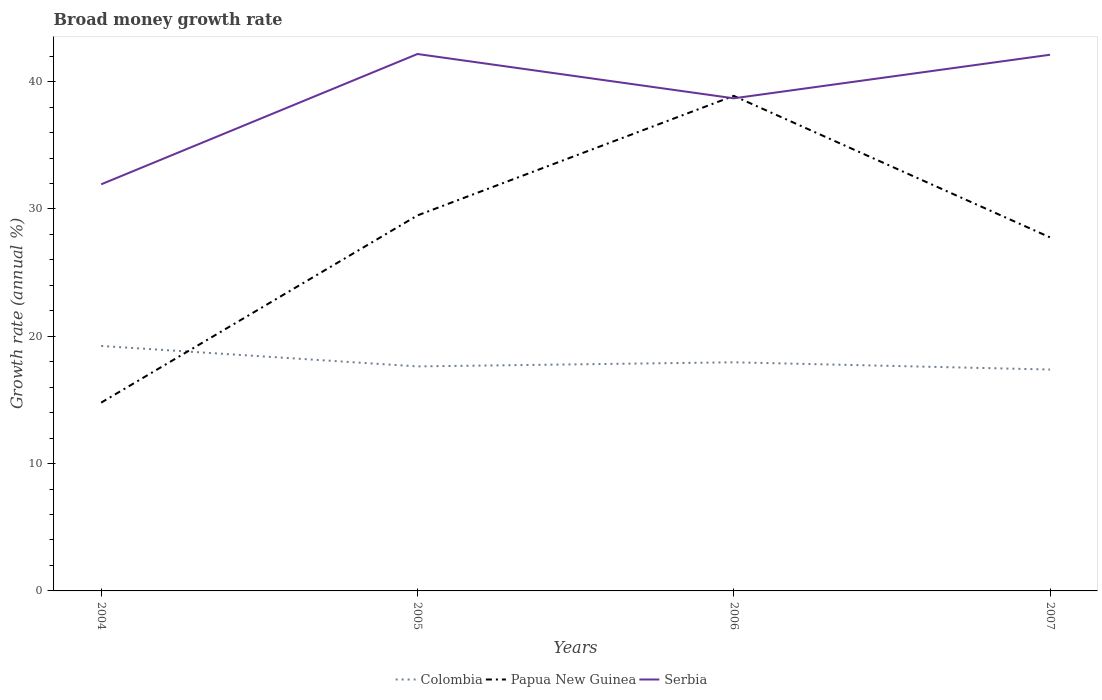How many different coloured lines are there?
Your answer should be very brief. 3. Across all years, what is the maximum growth rate in Papua New Guinea?
Provide a succinct answer. 14.79. In which year was the growth rate in Papua New Guinea maximum?
Your answer should be very brief. 2004. What is the total growth rate in Papua New Guinea in the graph?
Provide a succinct answer. -12.98. What is the difference between the highest and the second highest growth rate in Papua New Guinea?
Give a very brief answer. 24.09. What is the difference between the highest and the lowest growth rate in Serbia?
Offer a very short reply. 2. Is the growth rate in Papua New Guinea strictly greater than the growth rate in Colombia over the years?
Ensure brevity in your answer.  No. How many lines are there?
Your answer should be very brief. 3. How many years are there in the graph?
Provide a succinct answer. 4. Are the values on the major ticks of Y-axis written in scientific E-notation?
Your answer should be very brief. No. Does the graph contain any zero values?
Keep it short and to the point. No. Does the graph contain grids?
Provide a short and direct response. No. How are the legend labels stacked?
Keep it short and to the point. Horizontal. What is the title of the graph?
Give a very brief answer. Broad money growth rate. What is the label or title of the Y-axis?
Your answer should be compact. Growth rate (annual %). What is the Growth rate (annual %) in Colombia in 2004?
Ensure brevity in your answer.  19.24. What is the Growth rate (annual %) in Papua New Guinea in 2004?
Your answer should be very brief. 14.79. What is the Growth rate (annual %) of Serbia in 2004?
Offer a terse response. 31.93. What is the Growth rate (annual %) of Colombia in 2005?
Keep it short and to the point. 17.63. What is the Growth rate (annual %) of Papua New Guinea in 2005?
Provide a short and direct response. 29.49. What is the Growth rate (annual %) of Serbia in 2005?
Your answer should be very brief. 42.17. What is the Growth rate (annual %) of Colombia in 2006?
Ensure brevity in your answer.  17.95. What is the Growth rate (annual %) of Papua New Guinea in 2006?
Your answer should be compact. 38.88. What is the Growth rate (annual %) in Serbia in 2006?
Your response must be concise. 38.69. What is the Growth rate (annual %) in Colombia in 2007?
Ensure brevity in your answer.  17.39. What is the Growth rate (annual %) in Papua New Guinea in 2007?
Ensure brevity in your answer.  27.76. What is the Growth rate (annual %) of Serbia in 2007?
Make the answer very short. 42.11. Across all years, what is the maximum Growth rate (annual %) in Colombia?
Offer a very short reply. 19.24. Across all years, what is the maximum Growth rate (annual %) in Papua New Guinea?
Your answer should be very brief. 38.88. Across all years, what is the maximum Growth rate (annual %) of Serbia?
Ensure brevity in your answer.  42.17. Across all years, what is the minimum Growth rate (annual %) of Colombia?
Your answer should be very brief. 17.39. Across all years, what is the minimum Growth rate (annual %) of Papua New Guinea?
Your answer should be very brief. 14.79. Across all years, what is the minimum Growth rate (annual %) in Serbia?
Provide a succinct answer. 31.93. What is the total Growth rate (annual %) of Colombia in the graph?
Provide a succinct answer. 72.21. What is the total Growth rate (annual %) in Papua New Guinea in the graph?
Your response must be concise. 110.92. What is the total Growth rate (annual %) in Serbia in the graph?
Make the answer very short. 154.9. What is the difference between the Growth rate (annual %) of Colombia in 2004 and that in 2005?
Ensure brevity in your answer.  1.61. What is the difference between the Growth rate (annual %) in Papua New Guinea in 2004 and that in 2005?
Provide a succinct answer. -14.7. What is the difference between the Growth rate (annual %) of Serbia in 2004 and that in 2005?
Provide a short and direct response. -10.23. What is the difference between the Growth rate (annual %) of Colombia in 2004 and that in 2006?
Keep it short and to the point. 1.29. What is the difference between the Growth rate (annual %) in Papua New Guinea in 2004 and that in 2006?
Make the answer very short. -24.09. What is the difference between the Growth rate (annual %) in Serbia in 2004 and that in 2006?
Offer a very short reply. -6.76. What is the difference between the Growth rate (annual %) in Colombia in 2004 and that in 2007?
Offer a terse response. 1.85. What is the difference between the Growth rate (annual %) of Papua New Guinea in 2004 and that in 2007?
Ensure brevity in your answer.  -12.98. What is the difference between the Growth rate (annual %) of Serbia in 2004 and that in 2007?
Offer a terse response. -10.18. What is the difference between the Growth rate (annual %) of Colombia in 2005 and that in 2006?
Provide a succinct answer. -0.32. What is the difference between the Growth rate (annual %) of Papua New Guinea in 2005 and that in 2006?
Your answer should be compact. -9.39. What is the difference between the Growth rate (annual %) in Serbia in 2005 and that in 2006?
Provide a short and direct response. 3.48. What is the difference between the Growth rate (annual %) of Colombia in 2005 and that in 2007?
Give a very brief answer. 0.25. What is the difference between the Growth rate (annual %) in Papua New Guinea in 2005 and that in 2007?
Give a very brief answer. 1.73. What is the difference between the Growth rate (annual %) in Serbia in 2005 and that in 2007?
Give a very brief answer. 0.06. What is the difference between the Growth rate (annual %) in Colombia in 2006 and that in 2007?
Offer a terse response. 0.57. What is the difference between the Growth rate (annual %) of Papua New Guinea in 2006 and that in 2007?
Offer a very short reply. 11.11. What is the difference between the Growth rate (annual %) in Serbia in 2006 and that in 2007?
Ensure brevity in your answer.  -3.42. What is the difference between the Growth rate (annual %) in Colombia in 2004 and the Growth rate (annual %) in Papua New Guinea in 2005?
Provide a short and direct response. -10.25. What is the difference between the Growth rate (annual %) of Colombia in 2004 and the Growth rate (annual %) of Serbia in 2005?
Give a very brief answer. -22.93. What is the difference between the Growth rate (annual %) in Papua New Guinea in 2004 and the Growth rate (annual %) in Serbia in 2005?
Offer a terse response. -27.38. What is the difference between the Growth rate (annual %) in Colombia in 2004 and the Growth rate (annual %) in Papua New Guinea in 2006?
Ensure brevity in your answer.  -19.64. What is the difference between the Growth rate (annual %) of Colombia in 2004 and the Growth rate (annual %) of Serbia in 2006?
Ensure brevity in your answer.  -19.45. What is the difference between the Growth rate (annual %) of Papua New Guinea in 2004 and the Growth rate (annual %) of Serbia in 2006?
Offer a terse response. -23.9. What is the difference between the Growth rate (annual %) in Colombia in 2004 and the Growth rate (annual %) in Papua New Guinea in 2007?
Offer a terse response. -8.52. What is the difference between the Growth rate (annual %) in Colombia in 2004 and the Growth rate (annual %) in Serbia in 2007?
Make the answer very short. -22.87. What is the difference between the Growth rate (annual %) in Papua New Guinea in 2004 and the Growth rate (annual %) in Serbia in 2007?
Make the answer very short. -27.32. What is the difference between the Growth rate (annual %) of Colombia in 2005 and the Growth rate (annual %) of Papua New Guinea in 2006?
Give a very brief answer. -21.25. What is the difference between the Growth rate (annual %) in Colombia in 2005 and the Growth rate (annual %) in Serbia in 2006?
Your answer should be very brief. -21.06. What is the difference between the Growth rate (annual %) of Papua New Guinea in 2005 and the Growth rate (annual %) of Serbia in 2006?
Keep it short and to the point. -9.2. What is the difference between the Growth rate (annual %) in Colombia in 2005 and the Growth rate (annual %) in Papua New Guinea in 2007?
Keep it short and to the point. -10.13. What is the difference between the Growth rate (annual %) in Colombia in 2005 and the Growth rate (annual %) in Serbia in 2007?
Offer a terse response. -24.48. What is the difference between the Growth rate (annual %) in Papua New Guinea in 2005 and the Growth rate (annual %) in Serbia in 2007?
Your response must be concise. -12.62. What is the difference between the Growth rate (annual %) of Colombia in 2006 and the Growth rate (annual %) of Papua New Guinea in 2007?
Your answer should be very brief. -9.81. What is the difference between the Growth rate (annual %) of Colombia in 2006 and the Growth rate (annual %) of Serbia in 2007?
Give a very brief answer. -24.15. What is the difference between the Growth rate (annual %) of Papua New Guinea in 2006 and the Growth rate (annual %) of Serbia in 2007?
Offer a terse response. -3.23. What is the average Growth rate (annual %) in Colombia per year?
Make the answer very short. 18.05. What is the average Growth rate (annual %) in Papua New Guinea per year?
Offer a very short reply. 27.73. What is the average Growth rate (annual %) of Serbia per year?
Make the answer very short. 38.72. In the year 2004, what is the difference between the Growth rate (annual %) in Colombia and Growth rate (annual %) in Papua New Guinea?
Provide a succinct answer. 4.45. In the year 2004, what is the difference between the Growth rate (annual %) of Colombia and Growth rate (annual %) of Serbia?
Your answer should be very brief. -12.69. In the year 2004, what is the difference between the Growth rate (annual %) in Papua New Guinea and Growth rate (annual %) in Serbia?
Give a very brief answer. -17.15. In the year 2005, what is the difference between the Growth rate (annual %) of Colombia and Growth rate (annual %) of Papua New Guinea?
Your answer should be compact. -11.86. In the year 2005, what is the difference between the Growth rate (annual %) of Colombia and Growth rate (annual %) of Serbia?
Provide a short and direct response. -24.54. In the year 2005, what is the difference between the Growth rate (annual %) of Papua New Guinea and Growth rate (annual %) of Serbia?
Your response must be concise. -12.68. In the year 2006, what is the difference between the Growth rate (annual %) of Colombia and Growth rate (annual %) of Papua New Guinea?
Ensure brevity in your answer.  -20.92. In the year 2006, what is the difference between the Growth rate (annual %) in Colombia and Growth rate (annual %) in Serbia?
Offer a very short reply. -20.73. In the year 2006, what is the difference between the Growth rate (annual %) of Papua New Guinea and Growth rate (annual %) of Serbia?
Your response must be concise. 0.19. In the year 2007, what is the difference between the Growth rate (annual %) in Colombia and Growth rate (annual %) in Papua New Guinea?
Ensure brevity in your answer.  -10.38. In the year 2007, what is the difference between the Growth rate (annual %) in Colombia and Growth rate (annual %) in Serbia?
Ensure brevity in your answer.  -24.72. In the year 2007, what is the difference between the Growth rate (annual %) in Papua New Guinea and Growth rate (annual %) in Serbia?
Offer a very short reply. -14.34. What is the ratio of the Growth rate (annual %) in Colombia in 2004 to that in 2005?
Offer a very short reply. 1.09. What is the ratio of the Growth rate (annual %) in Papua New Guinea in 2004 to that in 2005?
Your answer should be very brief. 0.5. What is the ratio of the Growth rate (annual %) in Serbia in 2004 to that in 2005?
Your answer should be compact. 0.76. What is the ratio of the Growth rate (annual %) of Colombia in 2004 to that in 2006?
Keep it short and to the point. 1.07. What is the ratio of the Growth rate (annual %) in Papua New Guinea in 2004 to that in 2006?
Your answer should be very brief. 0.38. What is the ratio of the Growth rate (annual %) of Serbia in 2004 to that in 2006?
Give a very brief answer. 0.83. What is the ratio of the Growth rate (annual %) of Colombia in 2004 to that in 2007?
Ensure brevity in your answer.  1.11. What is the ratio of the Growth rate (annual %) of Papua New Guinea in 2004 to that in 2007?
Your response must be concise. 0.53. What is the ratio of the Growth rate (annual %) in Serbia in 2004 to that in 2007?
Keep it short and to the point. 0.76. What is the ratio of the Growth rate (annual %) of Papua New Guinea in 2005 to that in 2006?
Provide a succinct answer. 0.76. What is the ratio of the Growth rate (annual %) of Serbia in 2005 to that in 2006?
Your answer should be compact. 1.09. What is the ratio of the Growth rate (annual %) in Colombia in 2005 to that in 2007?
Offer a very short reply. 1.01. What is the ratio of the Growth rate (annual %) of Papua New Guinea in 2005 to that in 2007?
Your answer should be compact. 1.06. What is the ratio of the Growth rate (annual %) in Colombia in 2006 to that in 2007?
Your answer should be compact. 1.03. What is the ratio of the Growth rate (annual %) of Papua New Guinea in 2006 to that in 2007?
Make the answer very short. 1.4. What is the ratio of the Growth rate (annual %) of Serbia in 2006 to that in 2007?
Ensure brevity in your answer.  0.92. What is the difference between the highest and the second highest Growth rate (annual %) in Colombia?
Provide a succinct answer. 1.29. What is the difference between the highest and the second highest Growth rate (annual %) of Papua New Guinea?
Give a very brief answer. 9.39. What is the difference between the highest and the second highest Growth rate (annual %) of Serbia?
Keep it short and to the point. 0.06. What is the difference between the highest and the lowest Growth rate (annual %) of Colombia?
Make the answer very short. 1.85. What is the difference between the highest and the lowest Growth rate (annual %) of Papua New Guinea?
Provide a succinct answer. 24.09. What is the difference between the highest and the lowest Growth rate (annual %) in Serbia?
Ensure brevity in your answer.  10.23. 